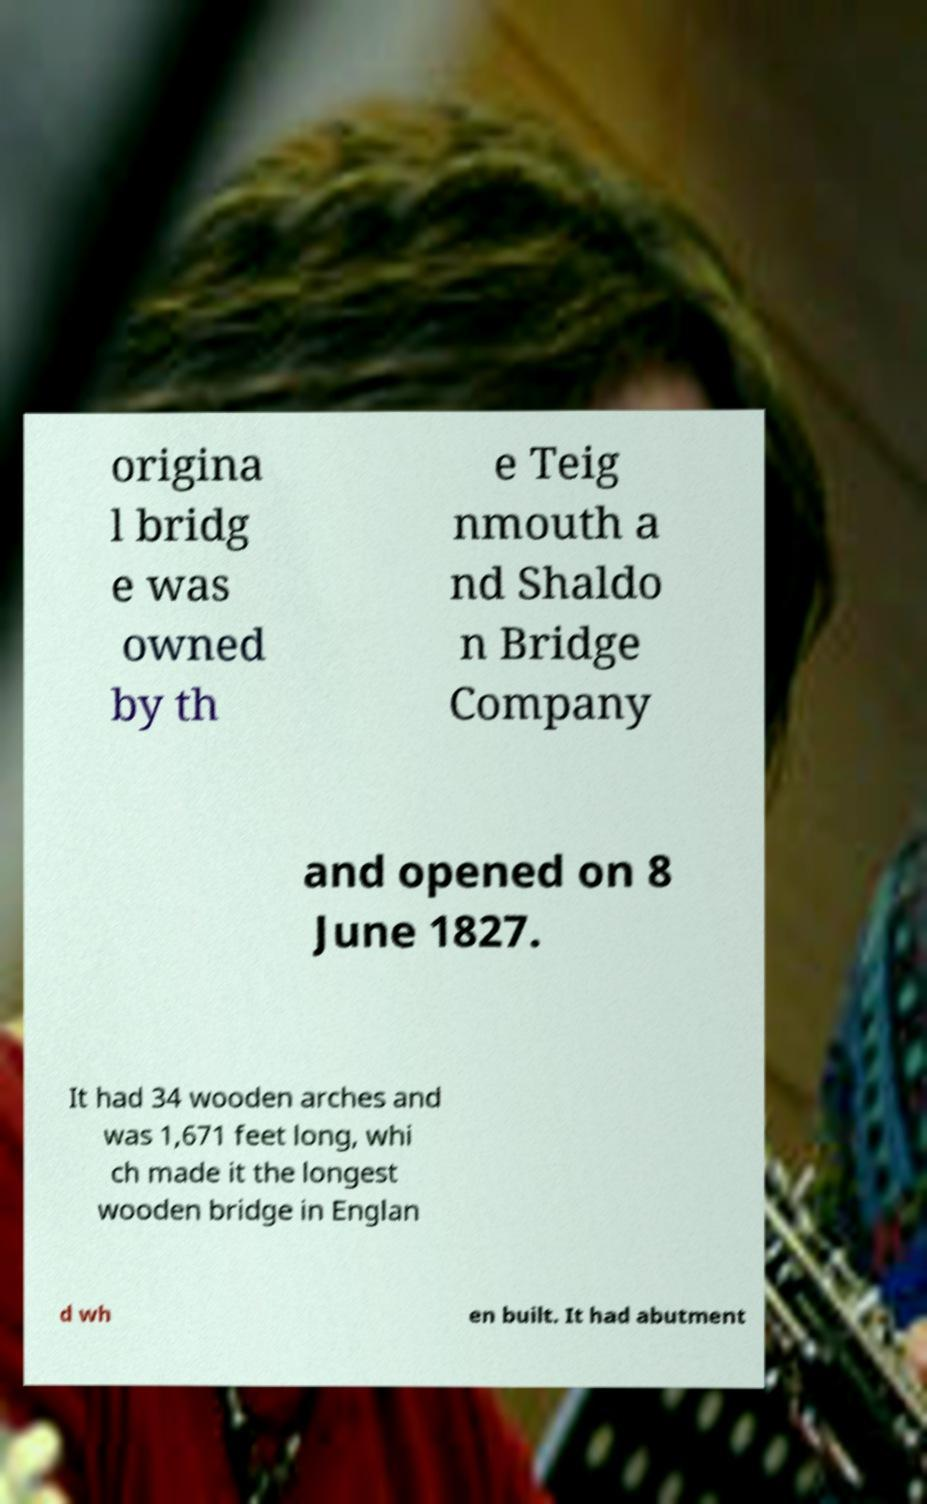What messages or text are displayed in this image? I need them in a readable, typed format. origina l bridg e was owned by th e Teig nmouth a nd Shaldo n Bridge Company and opened on 8 June 1827. It had 34 wooden arches and was 1,671 feet long, whi ch made it the longest wooden bridge in Englan d wh en built. It had abutment 